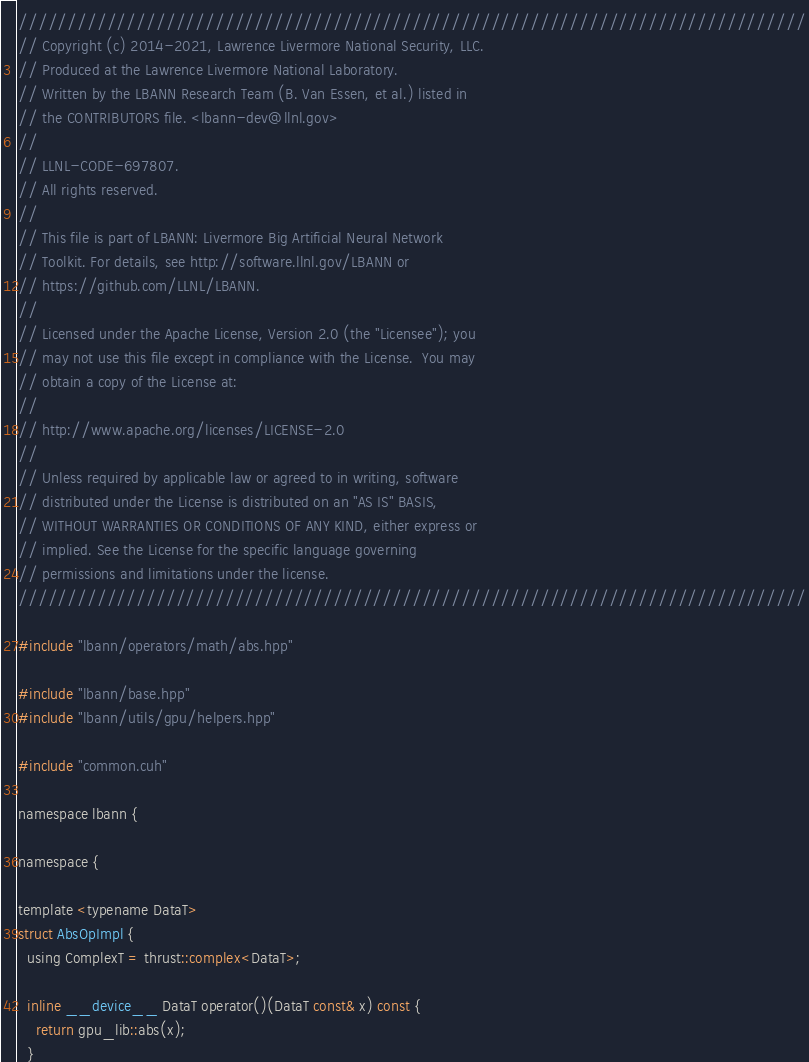<code> <loc_0><loc_0><loc_500><loc_500><_Cuda_>////////////////////////////////////////////////////////////////////////////////
// Copyright (c) 2014-2021, Lawrence Livermore National Security, LLC.
// Produced at the Lawrence Livermore National Laboratory.
// Written by the LBANN Research Team (B. Van Essen, et al.) listed in
// the CONTRIBUTORS file. <lbann-dev@llnl.gov>
//
// LLNL-CODE-697807.
// All rights reserved.
//
// This file is part of LBANN: Livermore Big Artificial Neural Network
// Toolkit. For details, see http://software.llnl.gov/LBANN or
// https://github.com/LLNL/LBANN.
//
// Licensed under the Apache License, Version 2.0 (the "Licensee"); you
// may not use this file except in compliance with the License.  You may
// obtain a copy of the License at:
//
// http://www.apache.org/licenses/LICENSE-2.0
//
// Unless required by applicable law or agreed to in writing, software
// distributed under the License is distributed on an "AS IS" BASIS,
// WITHOUT WARRANTIES OR CONDITIONS OF ANY KIND, either express or
// implied. See the License for the specific language governing
// permissions and limitations under the license.
////////////////////////////////////////////////////////////////////////////////

#include "lbann/operators/math/abs.hpp"

#include "lbann/base.hpp"
#include "lbann/utils/gpu/helpers.hpp"

#include "common.cuh"

namespace lbann {

namespace {

template <typename DataT>
struct AbsOpImpl {
  using ComplexT = thrust::complex<DataT>;

  inline __device__ DataT operator()(DataT const& x) const {
    return gpu_lib::abs(x);
  }</code> 